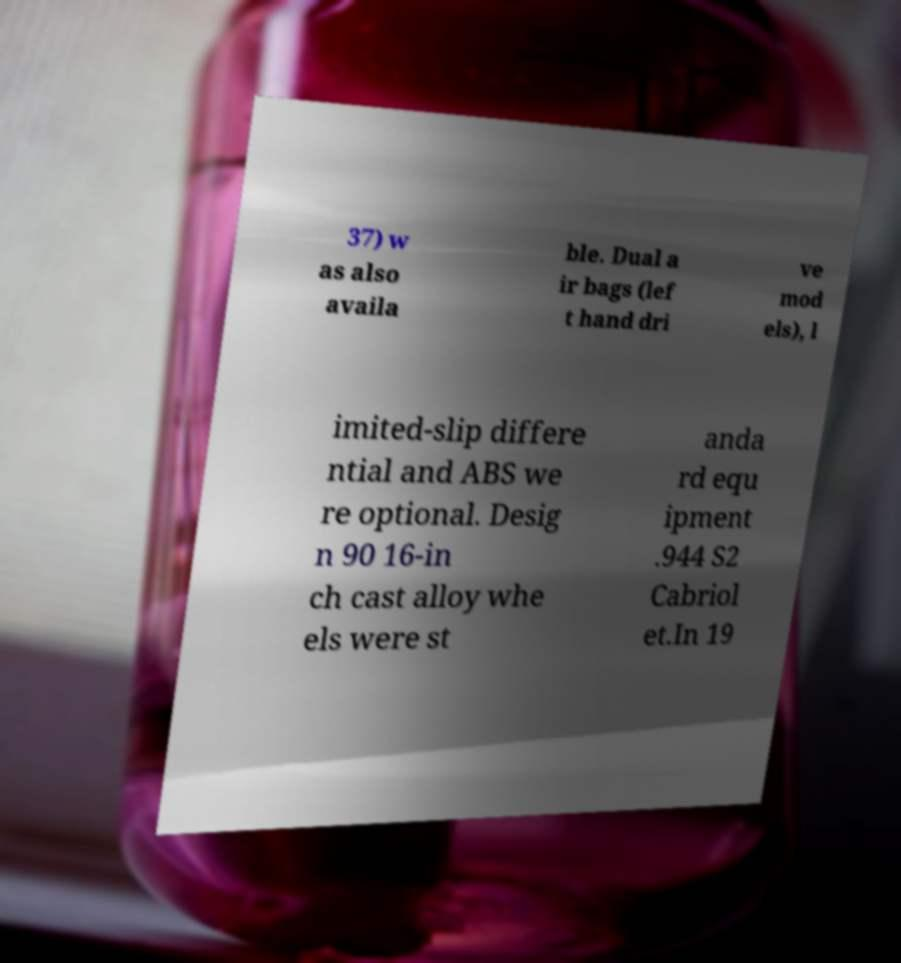There's text embedded in this image that I need extracted. Can you transcribe it verbatim? 37) w as also availa ble. Dual a ir bags (lef t hand dri ve mod els), l imited-slip differe ntial and ABS we re optional. Desig n 90 16-in ch cast alloy whe els were st anda rd equ ipment .944 S2 Cabriol et.In 19 